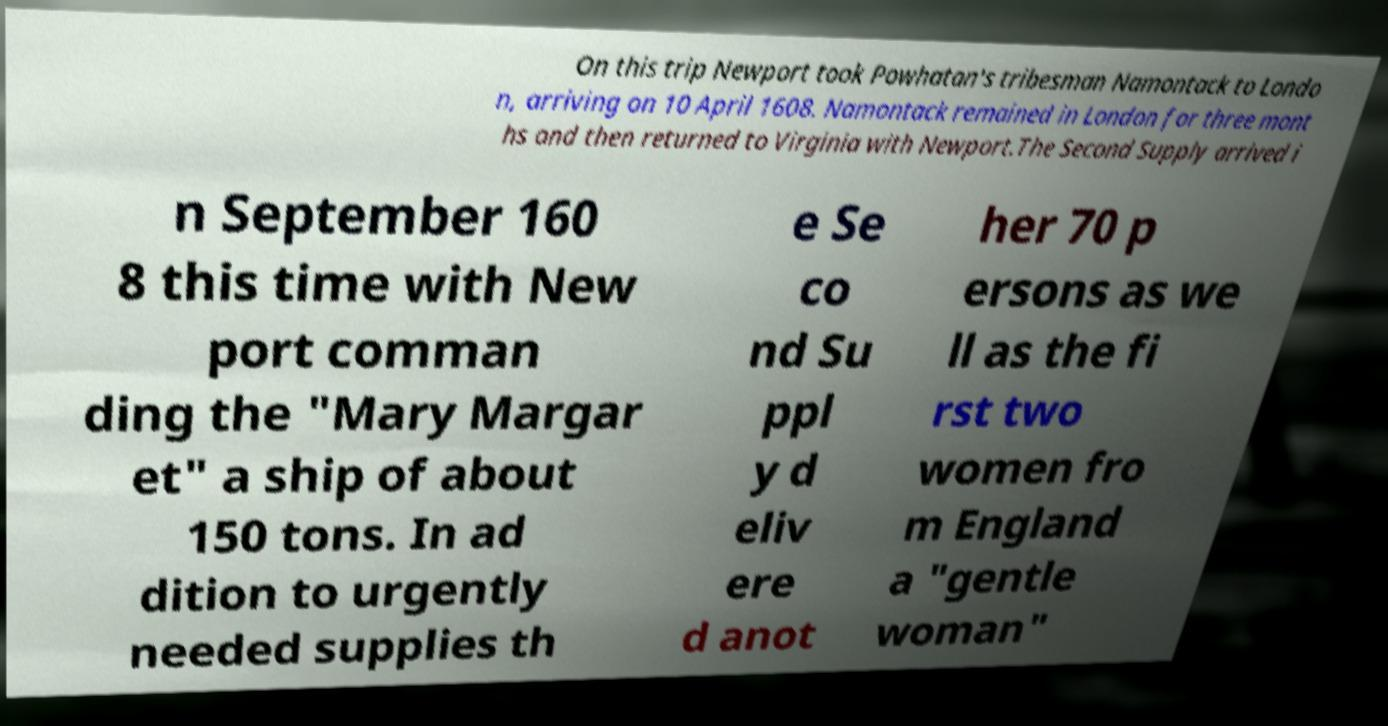What messages or text are displayed in this image? I need them in a readable, typed format. On this trip Newport took Powhatan's tribesman Namontack to Londo n, arriving on 10 April 1608. Namontack remained in London for three mont hs and then returned to Virginia with Newport.The Second Supply arrived i n September 160 8 this time with New port comman ding the "Mary Margar et" a ship of about 150 tons. In ad dition to urgently needed supplies th e Se co nd Su ppl y d eliv ere d anot her 70 p ersons as we ll as the fi rst two women fro m England a "gentle woman" 